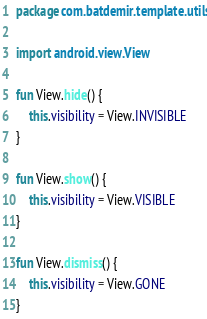<code> <loc_0><loc_0><loc_500><loc_500><_Kotlin_>package com.batdemir.template.utils

import android.view.View

fun View.hide() {
    this.visibility = View.INVISIBLE
}

fun View.show() {
    this.visibility = View.VISIBLE
}

fun View.dismiss() {
    this.visibility = View.GONE
}</code> 